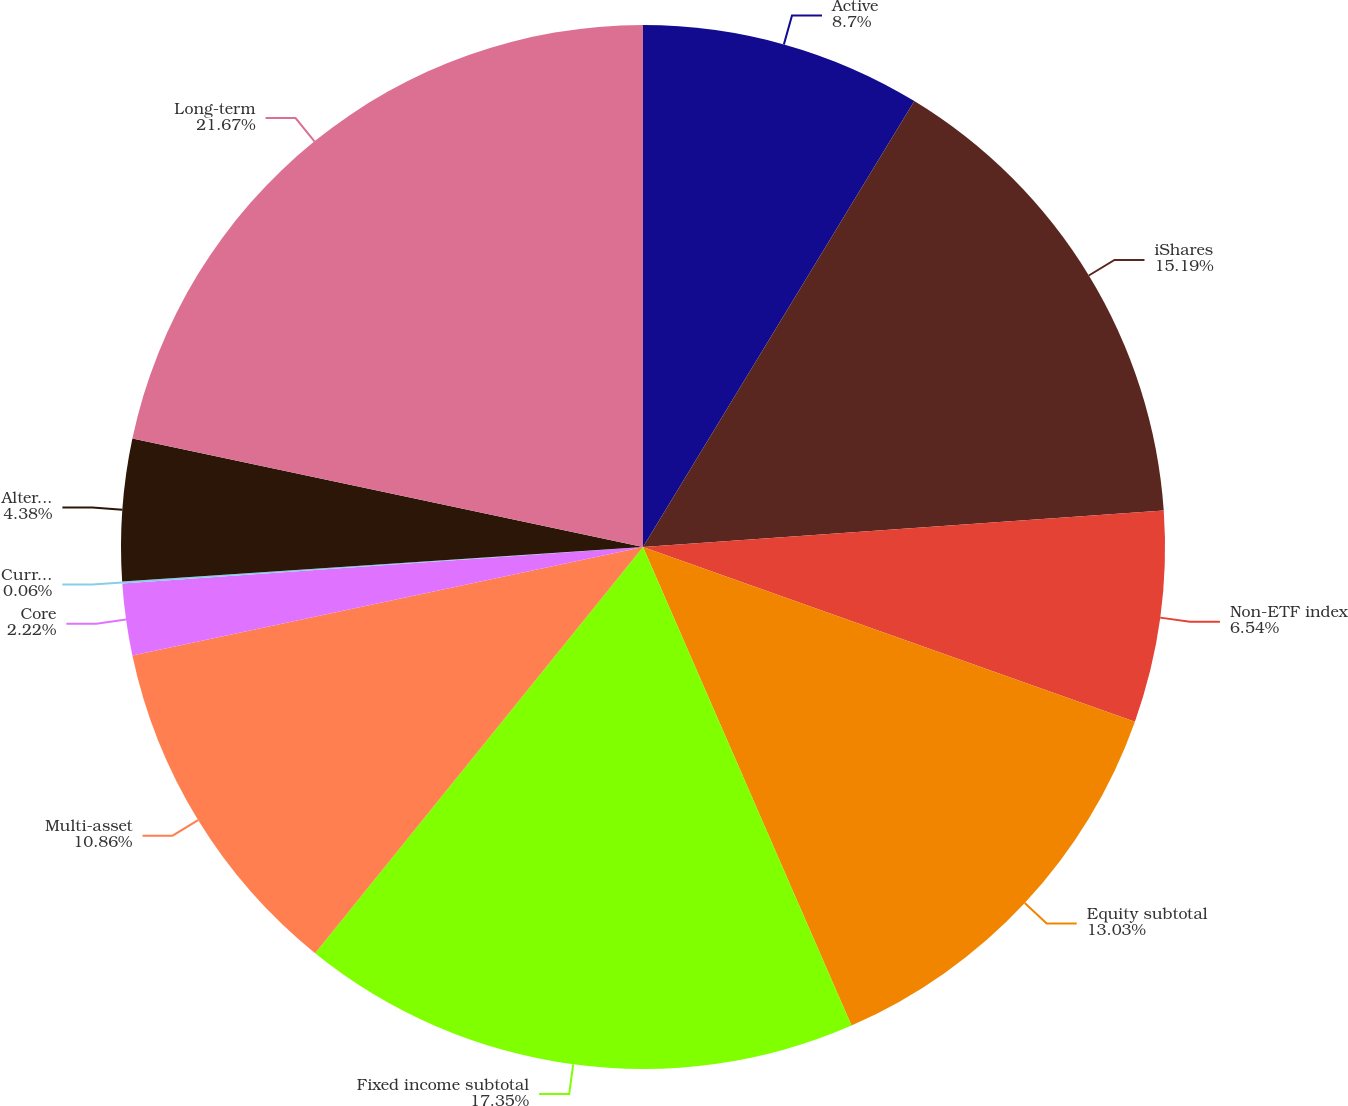Convert chart. <chart><loc_0><loc_0><loc_500><loc_500><pie_chart><fcel>Active<fcel>iShares<fcel>Non-ETF index<fcel>Equity subtotal<fcel>Fixed income subtotal<fcel>Multi-asset<fcel>Core<fcel>Currency and commodities (3)<fcel>Alternatives subtotal<fcel>Long-term<nl><fcel>8.7%<fcel>15.19%<fcel>6.54%<fcel>13.03%<fcel>17.35%<fcel>10.86%<fcel>2.22%<fcel>0.06%<fcel>4.38%<fcel>21.67%<nl></chart> 